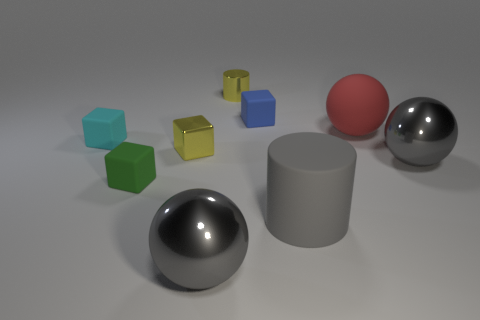What is the color of the cylinder that is to the left of the small object that is to the right of the small yellow cylinder?
Your answer should be very brief. Yellow. There is a red object that is made of the same material as the tiny green cube; what size is it?
Give a very brief answer. Large. How many small metal things are the same shape as the tiny green matte object?
Ensure brevity in your answer.  1. How many things are either things that are on the right side of the small cylinder or red rubber balls behind the large matte cylinder?
Make the answer very short. 4. There is a gray shiny thing that is right of the gray matte cylinder; how many cyan objects are to the left of it?
Provide a succinct answer. 1. Do the gray thing behind the small green rubber thing and the small rubber thing that is on the right side of the small yellow cylinder have the same shape?
Offer a terse response. No. The tiny thing that is the same color as the small metallic cube is what shape?
Give a very brief answer. Cylinder. Are there any big gray blocks that have the same material as the tiny green cube?
Give a very brief answer. No. What number of rubber objects are either gray cylinders or red balls?
Offer a very short reply. 2. There is a yellow thing on the right side of the large metal object that is left of the matte cylinder; what shape is it?
Keep it short and to the point. Cylinder. 